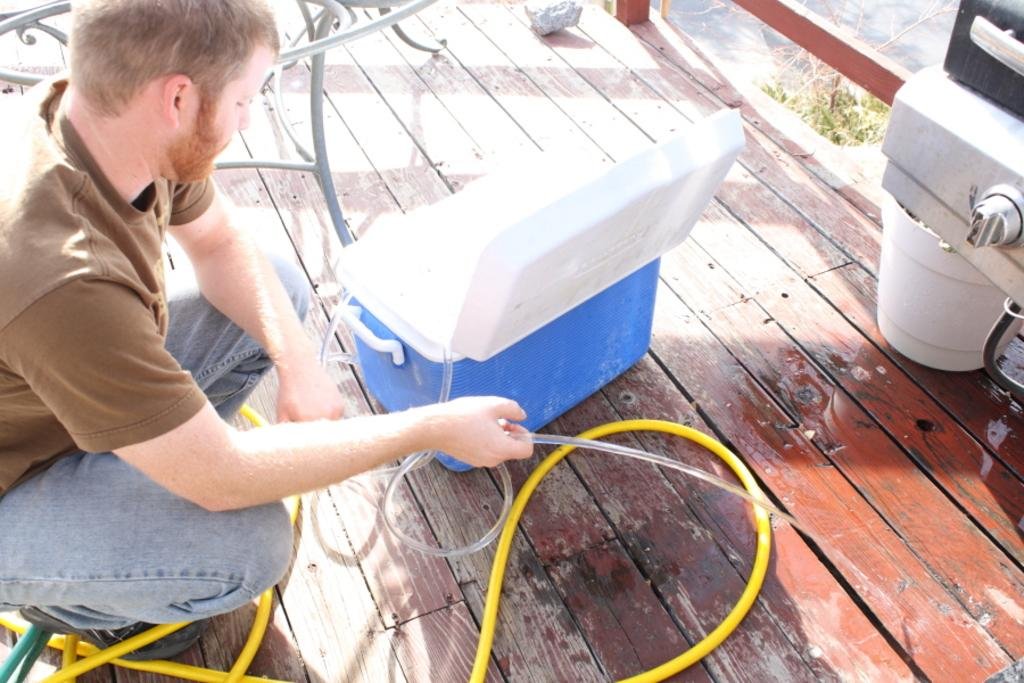What is the man in the image doing? The man is sitting in the image. What is the man holding in his hands? The man is holding a pipe in his hands. What is located in front of the man? There is a box in front of the man. What can be seen in the top right of the image? There are objects in the top right of the image. What is behind the man? There is a bench behind the man. How many cows are present in the image? There are no cows present in the image. What type of secretary is sitting next to the man? There is no secretary present in the image. 